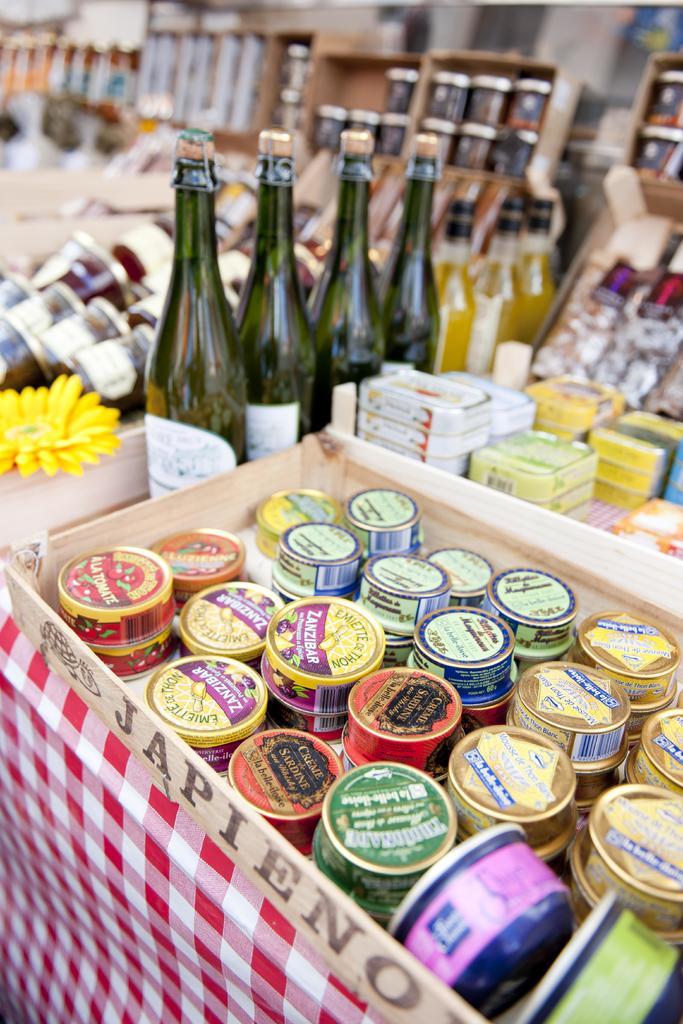What does the label at the front say?
Ensure brevity in your answer.  Japieno. What is on the purple banner on the yellow cans?
Make the answer very short. Zanzibar. 